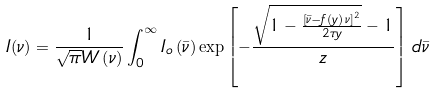<formula> <loc_0><loc_0><loc_500><loc_500>I ( \nu ) = \frac { 1 } { \sqrt { \pi } W \left ( \nu \right ) } \int _ { 0 } ^ { \infty } I _ { o } \left ( \bar { \nu } \right ) \exp \left [ - \frac { \sqrt { 1 - \frac { \left [ \bar { \nu } - f ( y ) \, \nu \right ] ^ { 2 } } { 2 \tau y } } - 1 } { z } \right ] \, d \bar { \nu }</formula> 